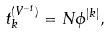Convert formula to latex. <formula><loc_0><loc_0><loc_500><loc_500>t _ { k } ^ { ( V ^ { - 1 } ) } = N \phi ^ { | k | } ,</formula> 